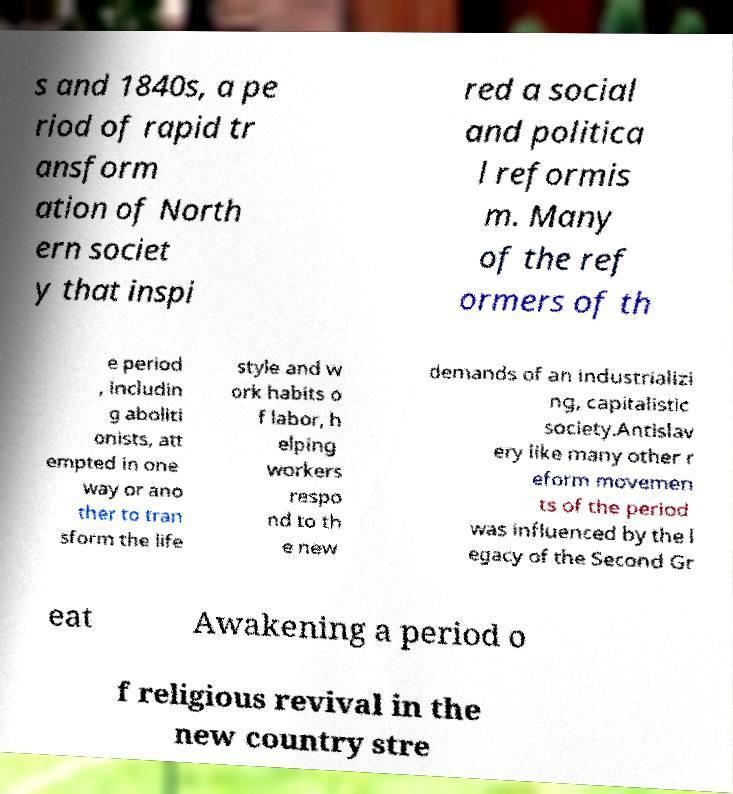Can you accurately transcribe the text from the provided image for me? s and 1840s, a pe riod of rapid tr ansform ation of North ern societ y that inspi red a social and politica l reformis m. Many of the ref ormers of th e period , includin g aboliti onists, att empted in one way or ano ther to tran sform the life style and w ork habits o f labor, h elping workers respo nd to th e new demands of an industrializi ng, capitalistic society.Antislav ery like many other r eform movemen ts of the period was influenced by the l egacy of the Second Gr eat Awakening a period o f religious revival in the new country stre 